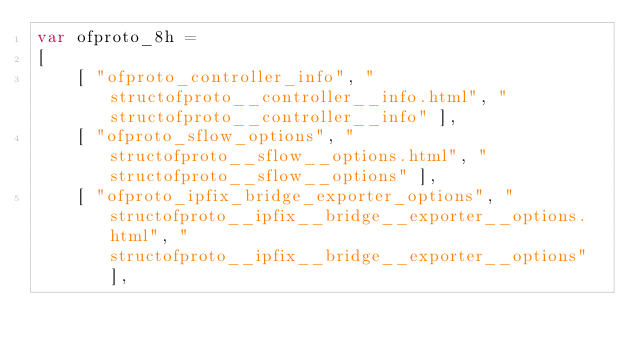Convert code to text. <code><loc_0><loc_0><loc_500><loc_500><_JavaScript_>var ofproto_8h =
[
    [ "ofproto_controller_info", "structofproto__controller__info.html", "structofproto__controller__info" ],
    [ "ofproto_sflow_options", "structofproto__sflow__options.html", "structofproto__sflow__options" ],
    [ "ofproto_ipfix_bridge_exporter_options", "structofproto__ipfix__bridge__exporter__options.html", "structofproto__ipfix__bridge__exporter__options" ],</code> 